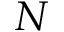Convert formula to latex. <formula><loc_0><loc_0><loc_500><loc_500>N</formula> 